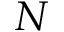Convert formula to latex. <formula><loc_0><loc_0><loc_500><loc_500>N</formula> 